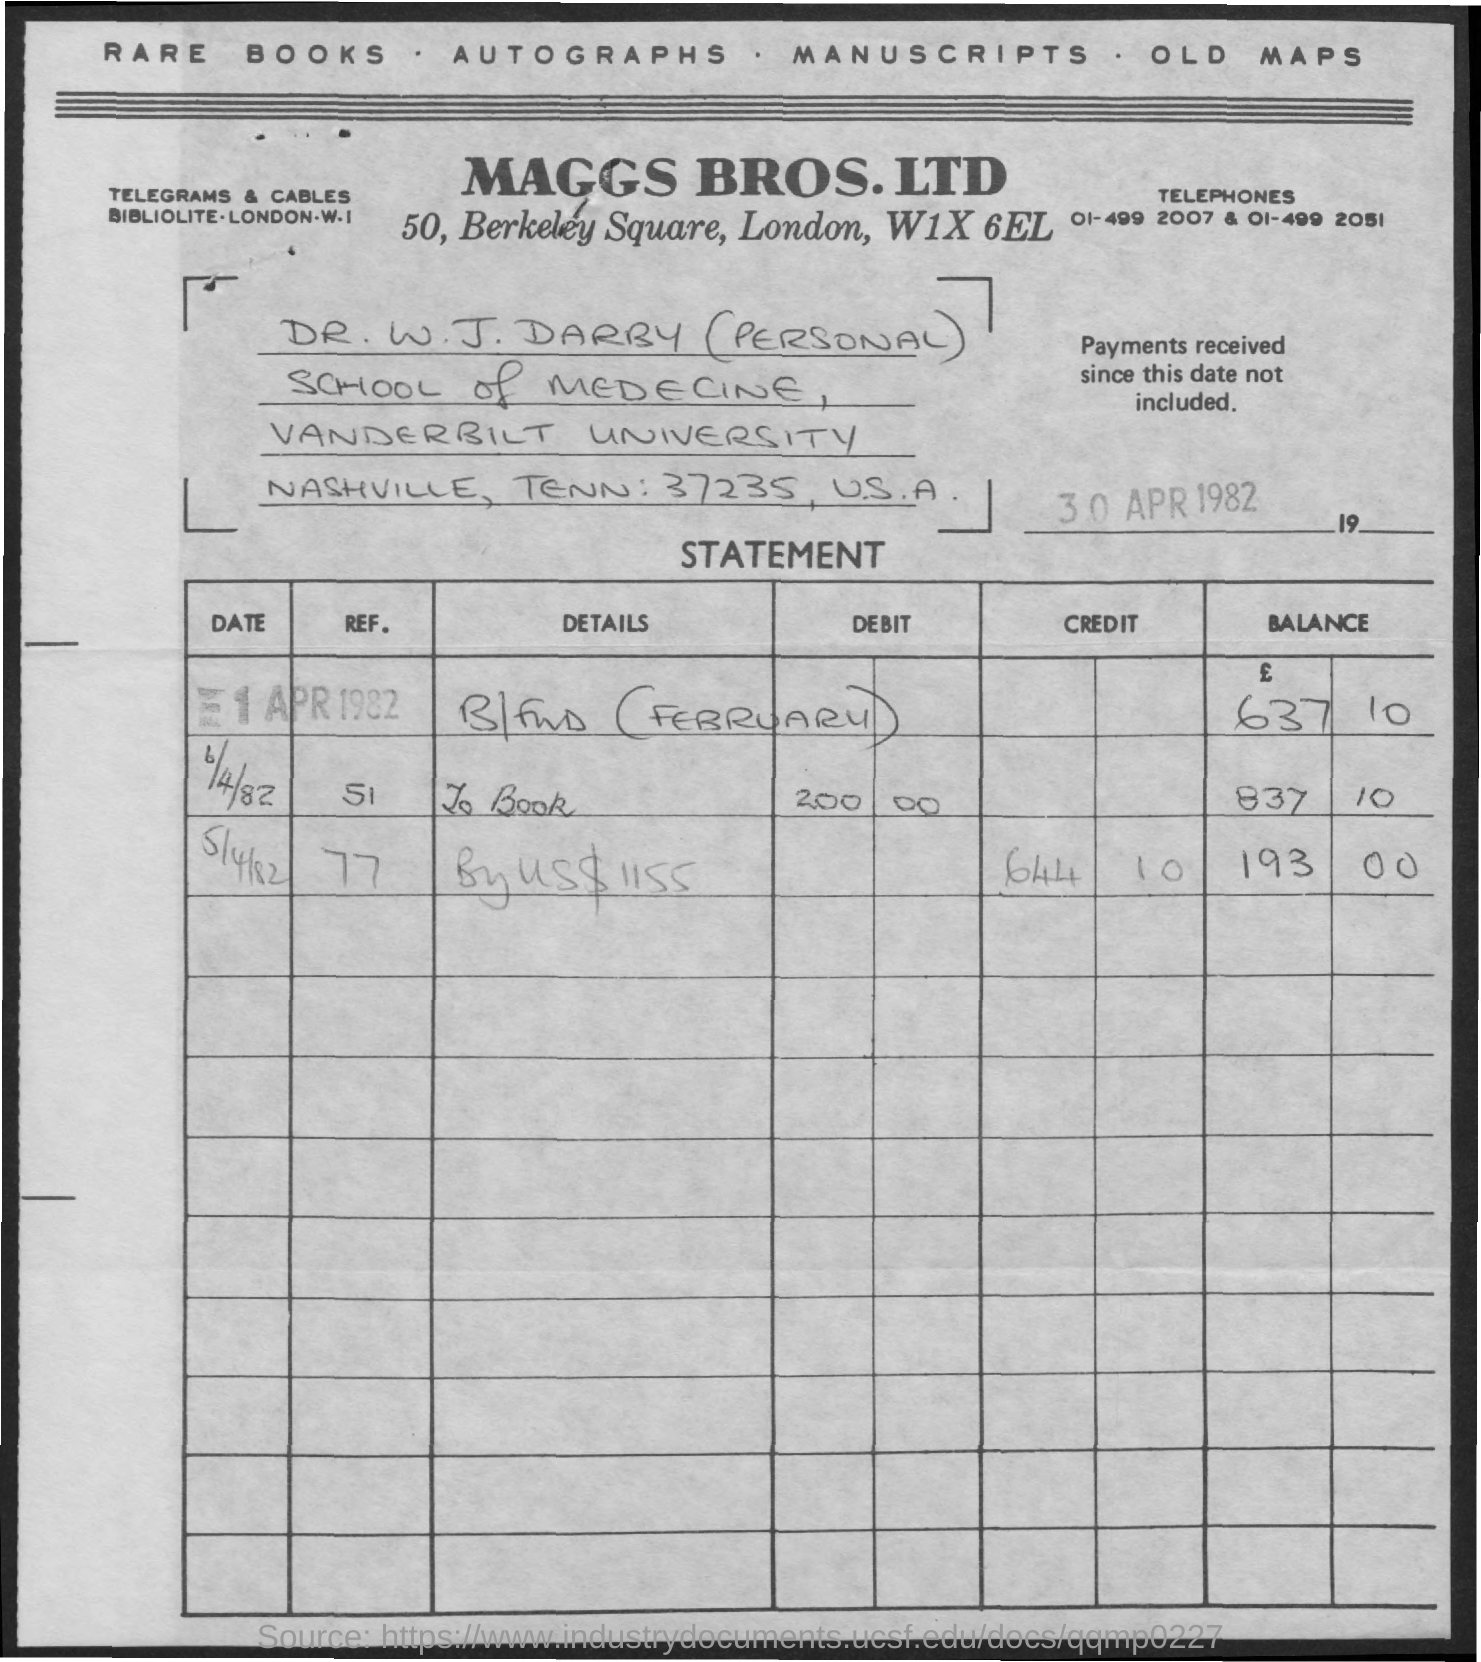Specify some key components in this picture. The document is dated April 30, 1982. 